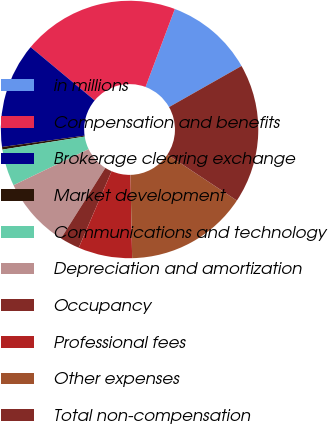<chart> <loc_0><loc_0><loc_500><loc_500><pie_chart><fcel>in millions<fcel>Compensation and benefits<fcel>Brokerage clearing exchange<fcel>Market development<fcel>Communications and technology<fcel>Depreciation and amortization<fcel>Occupancy<fcel>Professional fees<fcel>Other expenses<fcel>Total non-compensation<nl><fcel>11.07%<fcel>19.67%<fcel>13.22%<fcel>0.33%<fcel>4.63%<fcel>8.93%<fcel>2.48%<fcel>6.78%<fcel>15.37%<fcel>17.52%<nl></chart> 